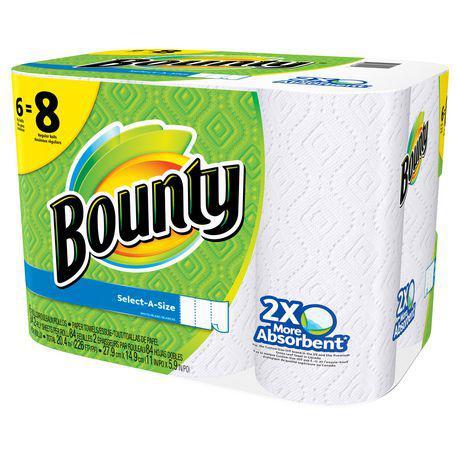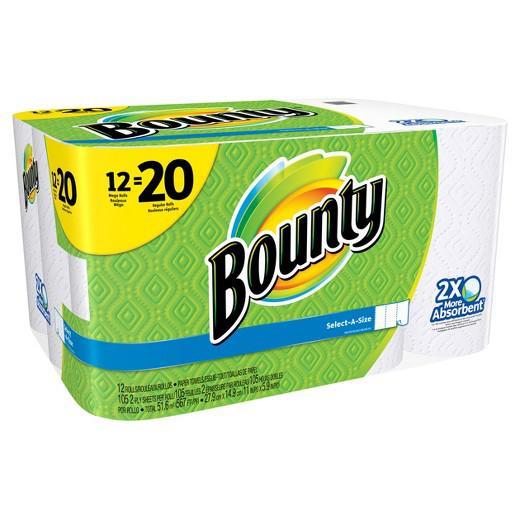The first image is the image on the left, the second image is the image on the right. Examine the images to the left and right. Is the description "There are 1 or more packages of paper towels facing right." accurate? Answer yes or no. Yes. 